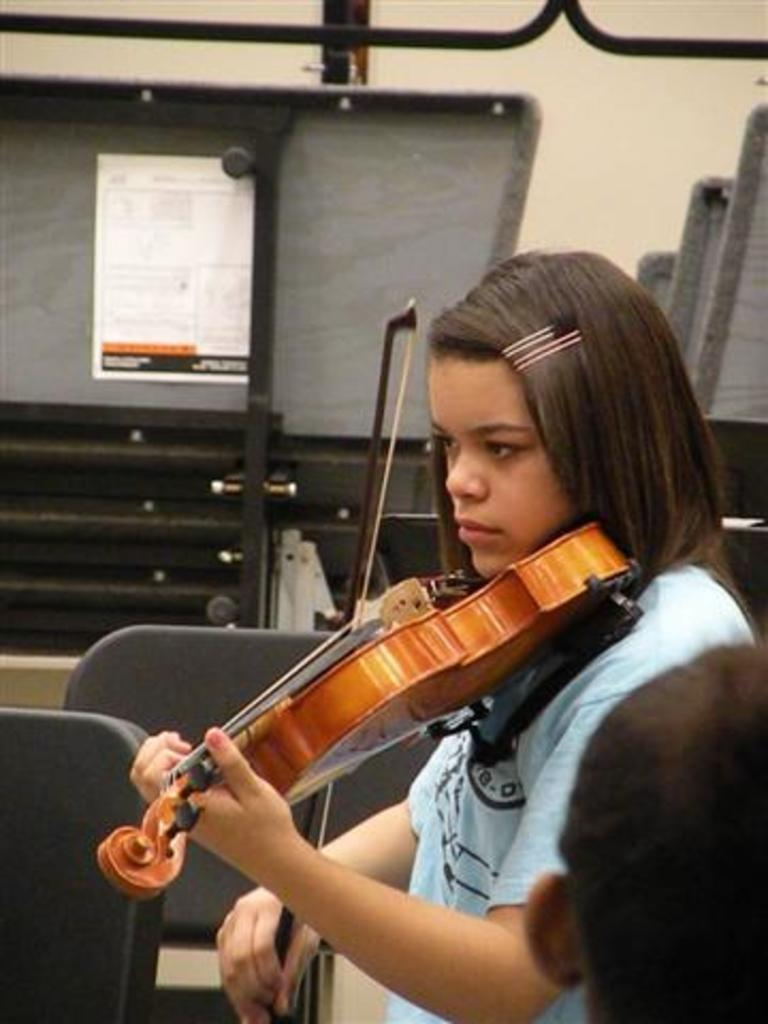What is the girl in the image doing? The girl is playing a guitar in the image. Who is the closest person to the camera in the image? There is a person in the foreground of the image. What can be seen behind the girl in the image? There are objects and a wall in the background of the image. What type of twig is the girl using to play the guitar in the image? The girl is not using a twig to play the guitar in the image; she is using a guitar. What kind of feast is being prepared in the background of the image? There is no feast being prepared in the image; the focus is on the girl playing the guitar and the person in the foreground. 